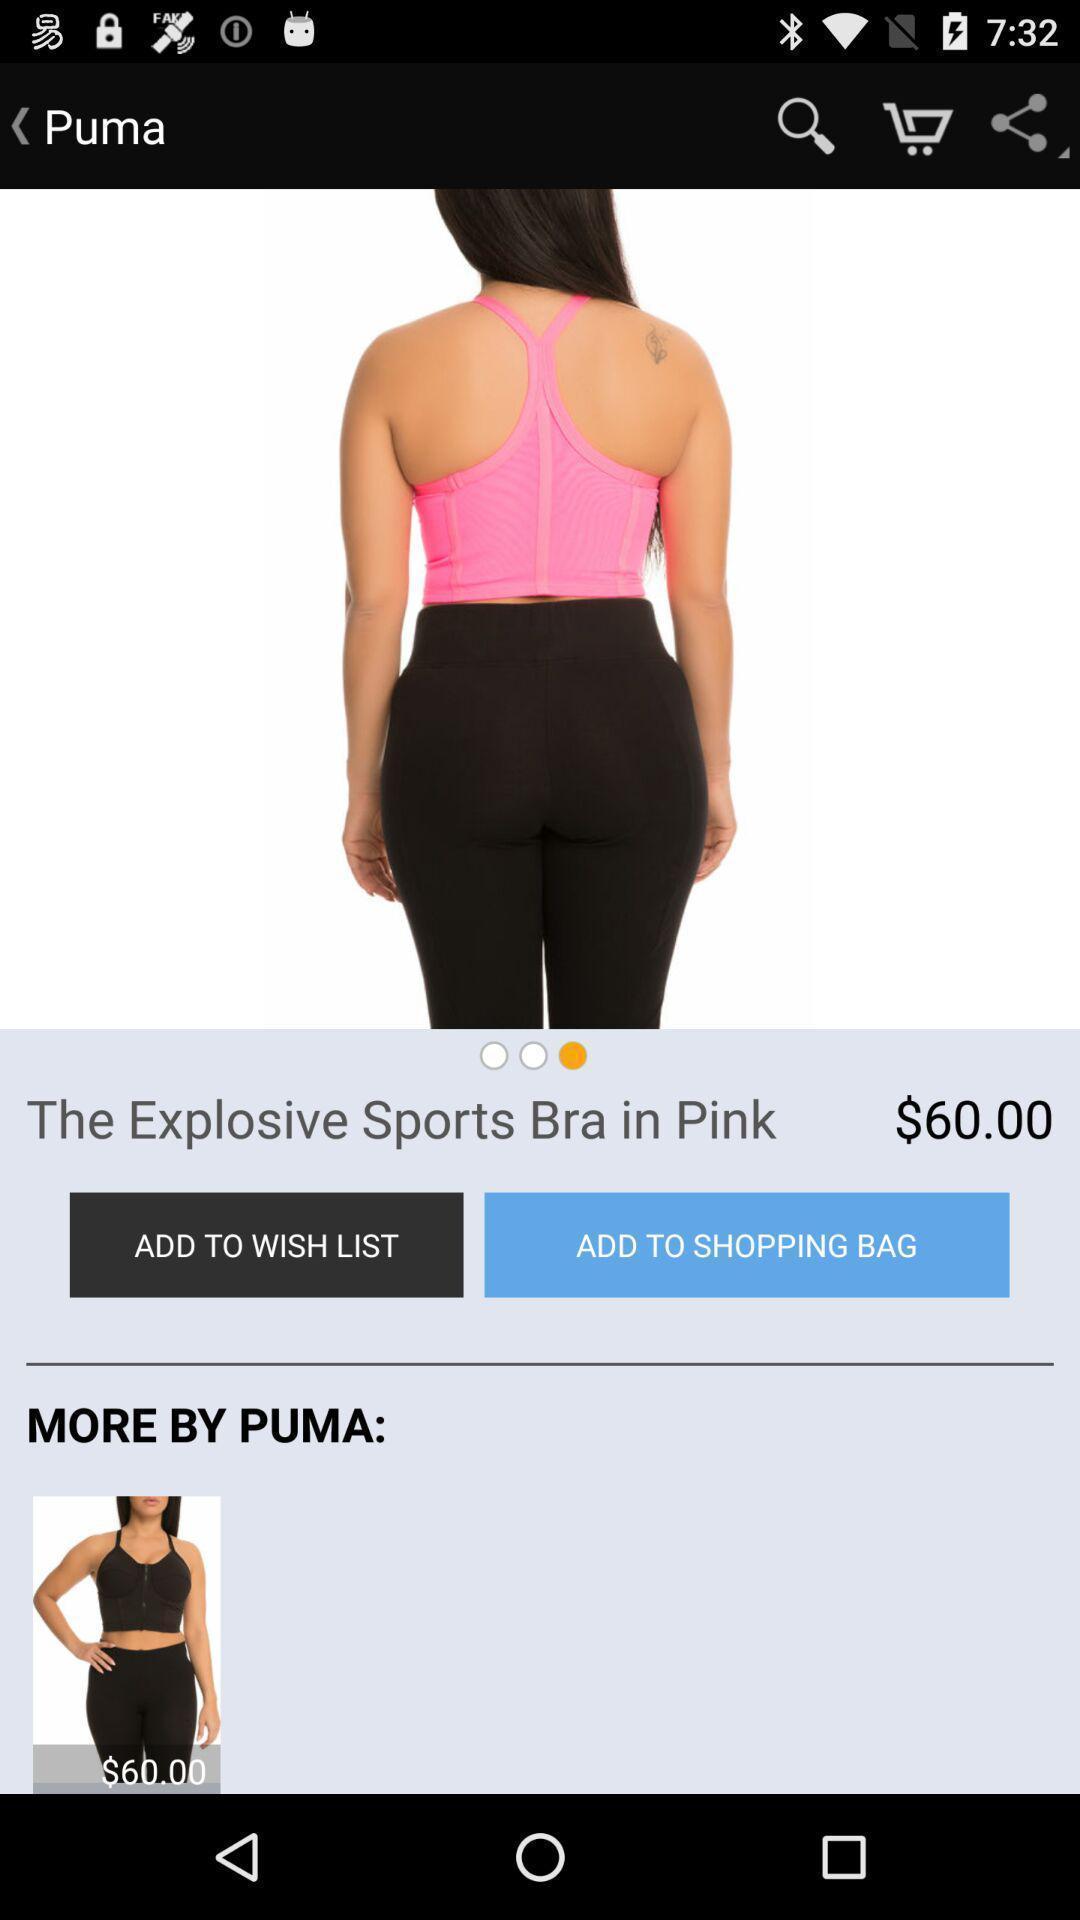Describe the visual elements of this screenshot. Shopping page. 